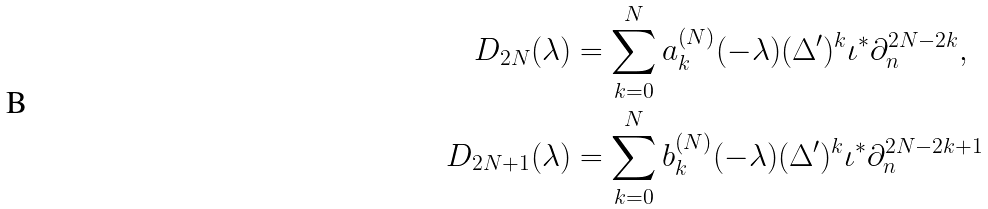<formula> <loc_0><loc_0><loc_500><loc_500>D _ { 2 N } ( \lambda ) & = \sum _ { k = 0 } ^ { N } a _ { k } ^ { ( N ) } ( - \lambda ) ( \Delta ^ { \prime } ) ^ { k } \iota ^ { * } \partial _ { n } ^ { 2 N - 2 k } , \\ D _ { 2 N + 1 } ( \lambda ) & = \sum _ { k = 0 } ^ { N } b _ { k } ^ { ( N ) } ( - \lambda ) ( \Delta ^ { \prime } ) ^ { k } \iota ^ { * } \partial _ { n } ^ { 2 N - 2 k + 1 }</formula> 